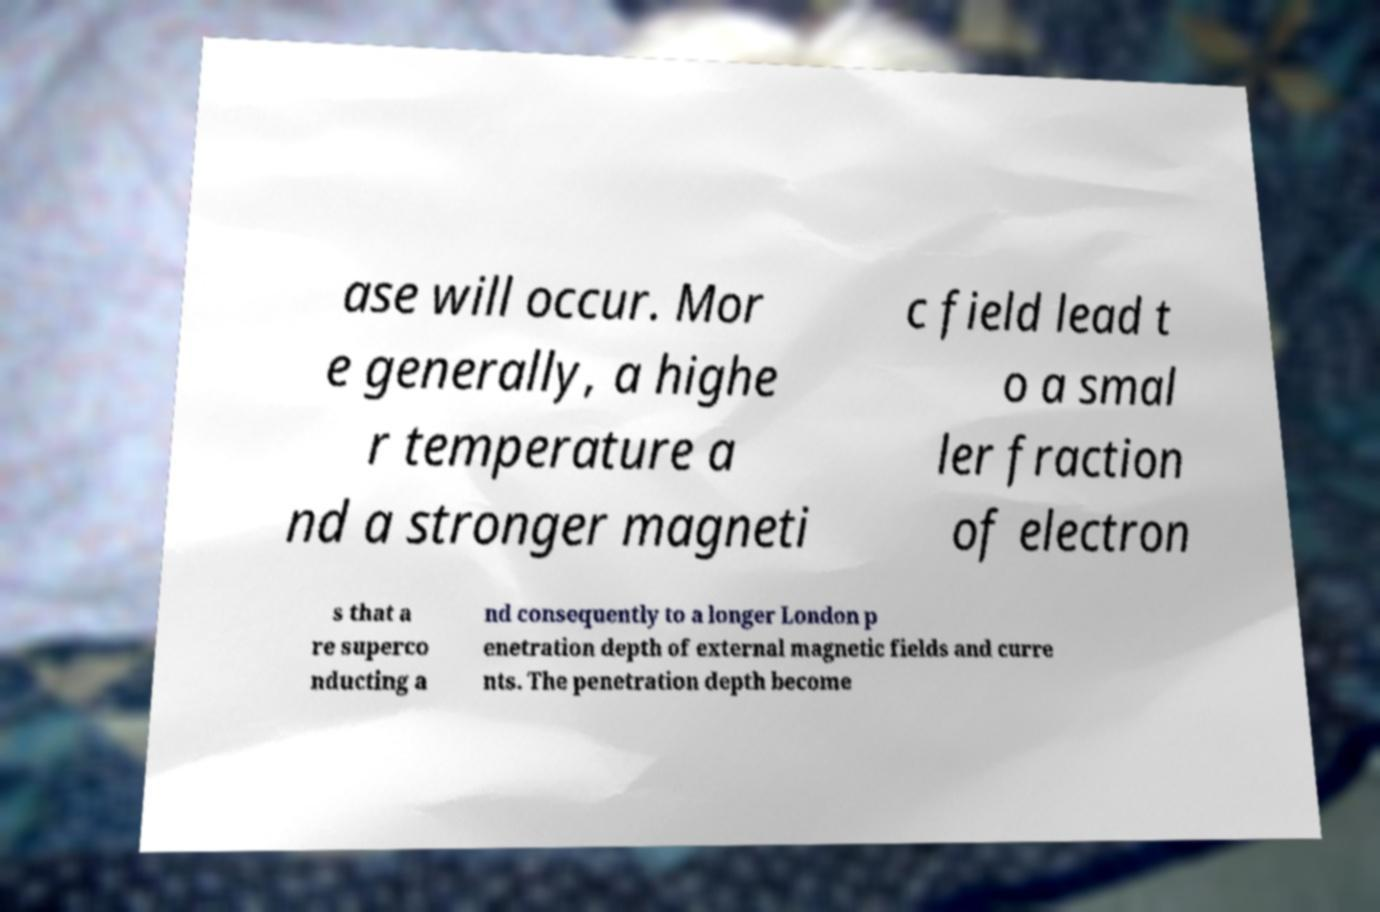Please identify and transcribe the text found in this image. ase will occur. Mor e generally, a highe r temperature a nd a stronger magneti c field lead t o a smal ler fraction of electron s that a re superco nducting a nd consequently to a longer London p enetration depth of external magnetic fields and curre nts. The penetration depth become 